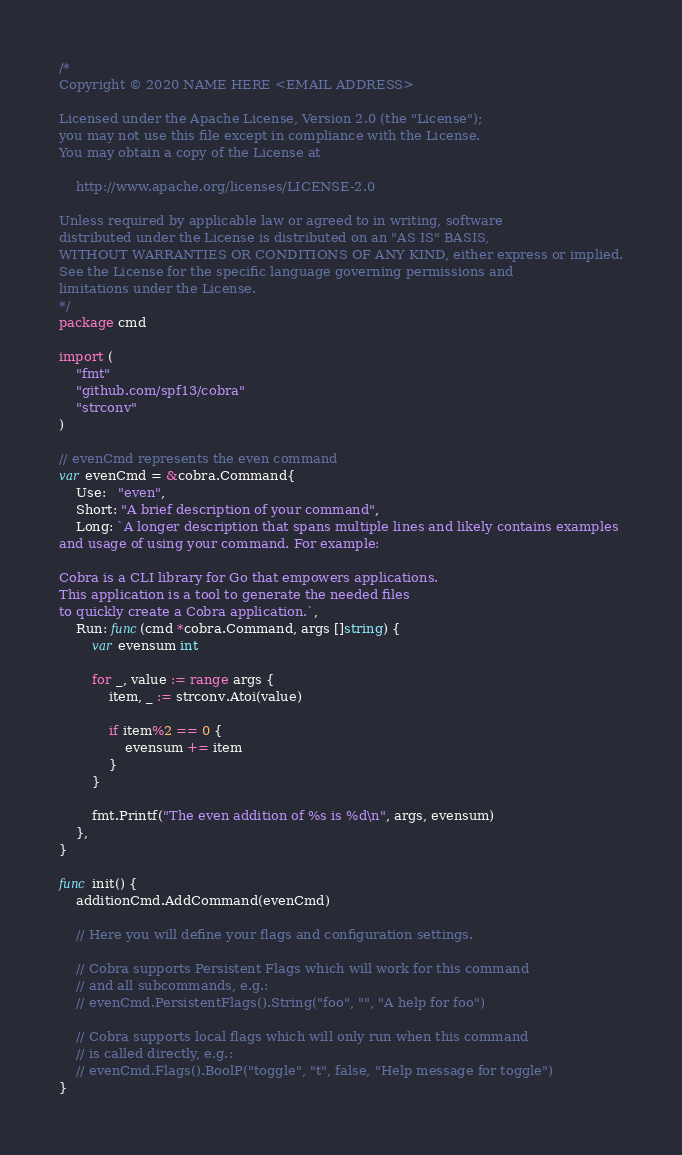Convert code to text. <code><loc_0><loc_0><loc_500><loc_500><_Go_>/*
Copyright © 2020 NAME HERE <EMAIL ADDRESS>

Licensed under the Apache License, Version 2.0 (the "License");
you may not use this file except in compliance with the License.
You may obtain a copy of the License at

    http://www.apache.org/licenses/LICENSE-2.0

Unless required by applicable law or agreed to in writing, software
distributed under the License is distributed on an "AS IS" BASIS,
WITHOUT WARRANTIES OR CONDITIONS OF ANY KIND, either express or implied.
See the License for the specific language governing permissions and
limitations under the License.
*/
package cmd

import (
	"fmt"
	"github.com/spf13/cobra"
	"strconv"
)

// evenCmd represents the even command
var evenCmd = &cobra.Command{
	Use:   "even",
	Short: "A brief description of your command",
	Long: `A longer description that spans multiple lines and likely contains examples
and usage of using your command. For example:

Cobra is a CLI library for Go that empowers applications.
This application is a tool to generate the needed files
to quickly create a Cobra application.`,
	Run: func(cmd *cobra.Command, args []string) {
		var evensum int

		for _, value := range args {
			item, _ := strconv.Atoi(value)

			if item%2 == 0 {
				evensum += item
			}
		}

		fmt.Printf("The even addition of %s is %d\n", args, evensum)
	},
}

func init() {
	additionCmd.AddCommand(evenCmd)

	// Here you will define your flags and configuration settings.

	// Cobra supports Persistent Flags which will work for this command
	// and all subcommands, e.g.:
	// evenCmd.PersistentFlags().String("foo", "", "A help for foo")

	// Cobra supports local flags which will only run when this command
	// is called directly, e.g.:
	// evenCmd.Flags().BoolP("toggle", "t", false, "Help message for toggle")
}
</code> 